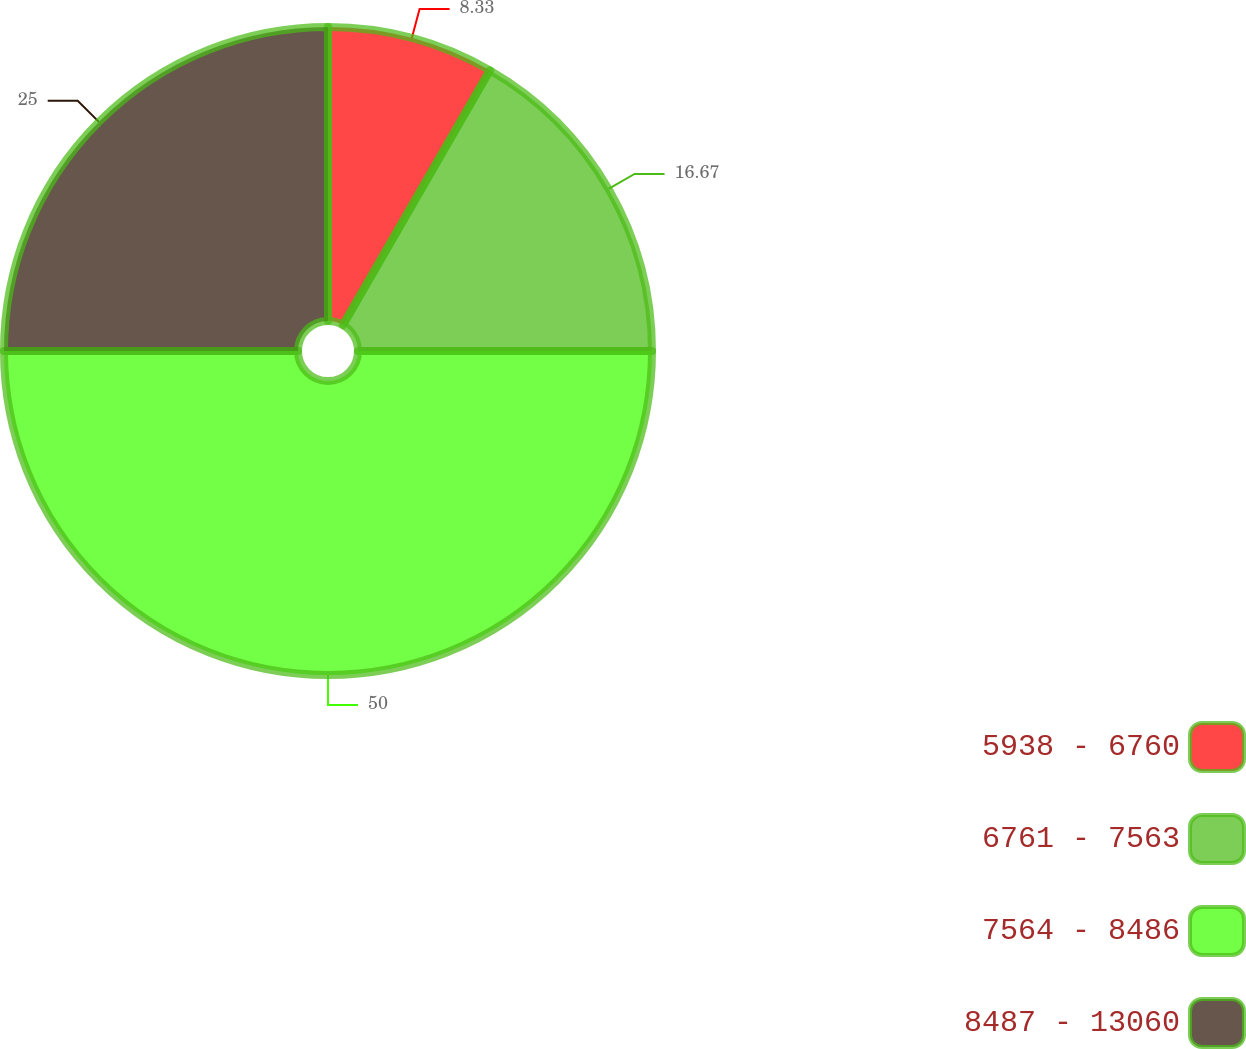Convert chart. <chart><loc_0><loc_0><loc_500><loc_500><pie_chart><fcel>5938 - 6760<fcel>6761 - 7563<fcel>7564 - 8486<fcel>8487 - 13060<nl><fcel>8.33%<fcel>16.67%<fcel>50.0%<fcel>25.0%<nl></chart> 